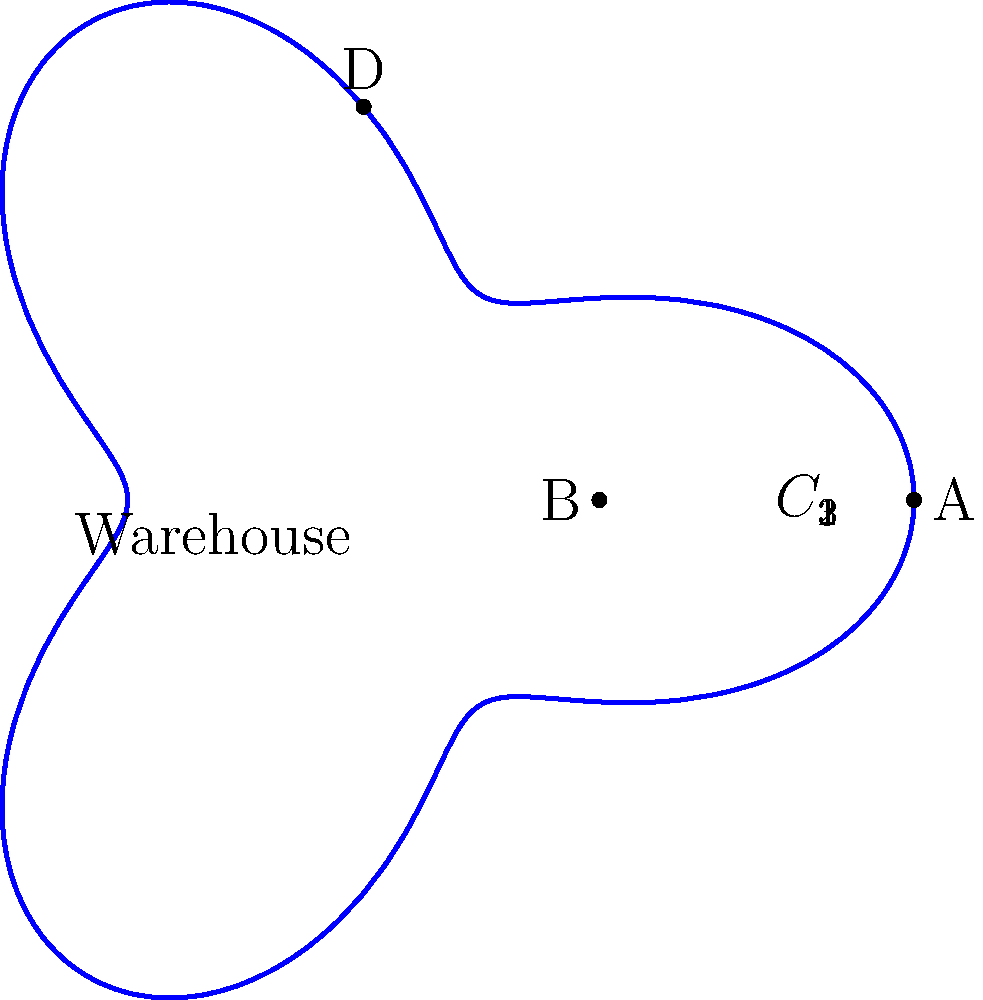In the polar coordinate map above, three potential delivery routes (C₁, C₂, C₃) are shown from the central warehouse. Points A, B, and D represent customer locations. Which route would be most efficient for delivering to all three customers in a single trip, assuming the driver must return to the warehouse? To determine the most efficient route, we need to consider the following steps:

1. Analyze the shape of the routes:
   The routes are represented by the polar equation $r = 5 + 2\cos(3\theta)$.

2. Identify customer locations:
   A: Located on the positive x-axis, furthest from the center.
   B: Located on the negative x-axis, closest to the center.
   D: Located on the positive y-axis.

3. Consider route characteristics:
   - All routes have three lobes due to the $\cos(3\theta)$ term.
   - The routes differ only in their rotation around the origin.

4. Evaluate each route:
   C₁: Passes close to A and B, but misses D.
   C₂: Passes close to B and D, but misses A.
   C₃: Passes close to A and D, but misses B.

5. Determine the optimal route:
   The most efficient route would be C₁ because:
   - It passes closest to both A and B.
   - Although it doesn't directly pass D, the detour to reach D is shorter compared to the detours needed for the other routes.

6. Propose the delivery sequence:
   Warehouse → B → A → D → Warehouse

This route minimizes the total distance traveled while ensuring all customers are served.
Answer: C₁ 